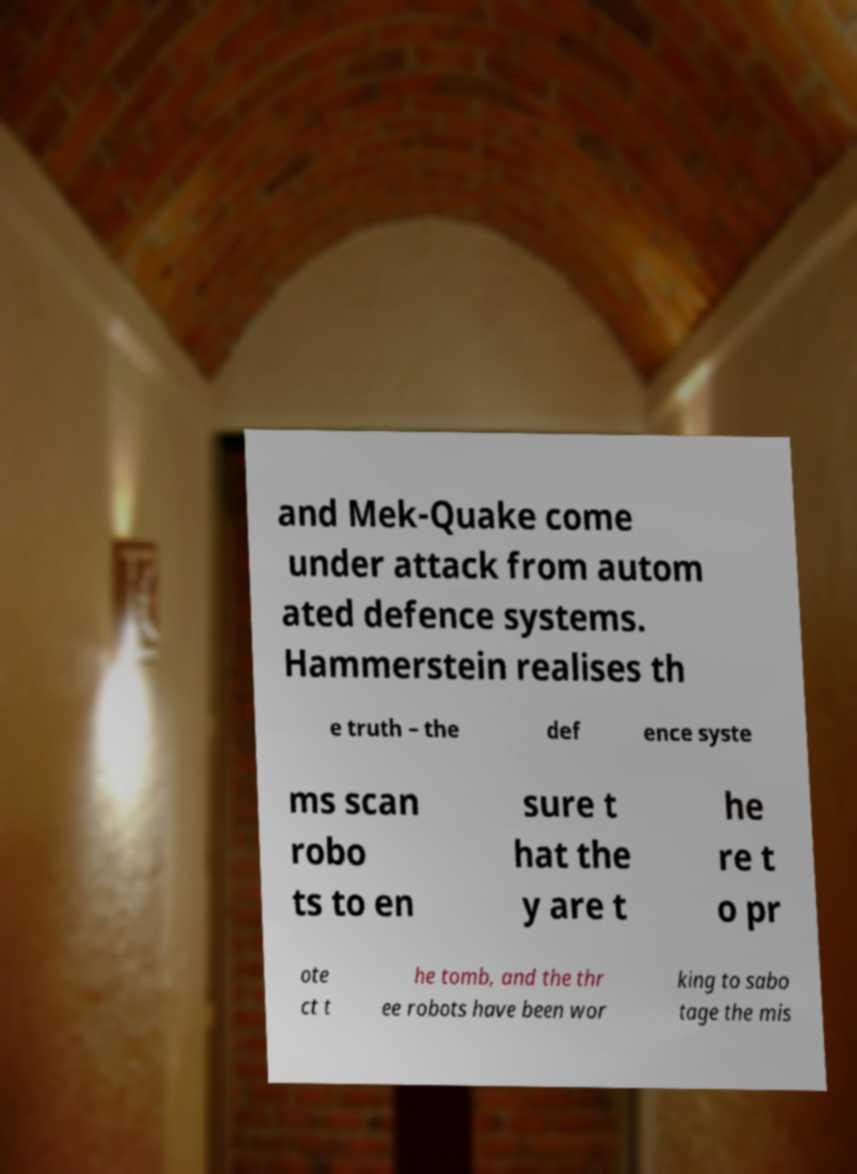I need the written content from this picture converted into text. Can you do that? and Mek-Quake come under attack from autom ated defence systems. Hammerstein realises th e truth – the def ence syste ms scan robo ts to en sure t hat the y are t he re t o pr ote ct t he tomb, and the thr ee robots have been wor king to sabo tage the mis 